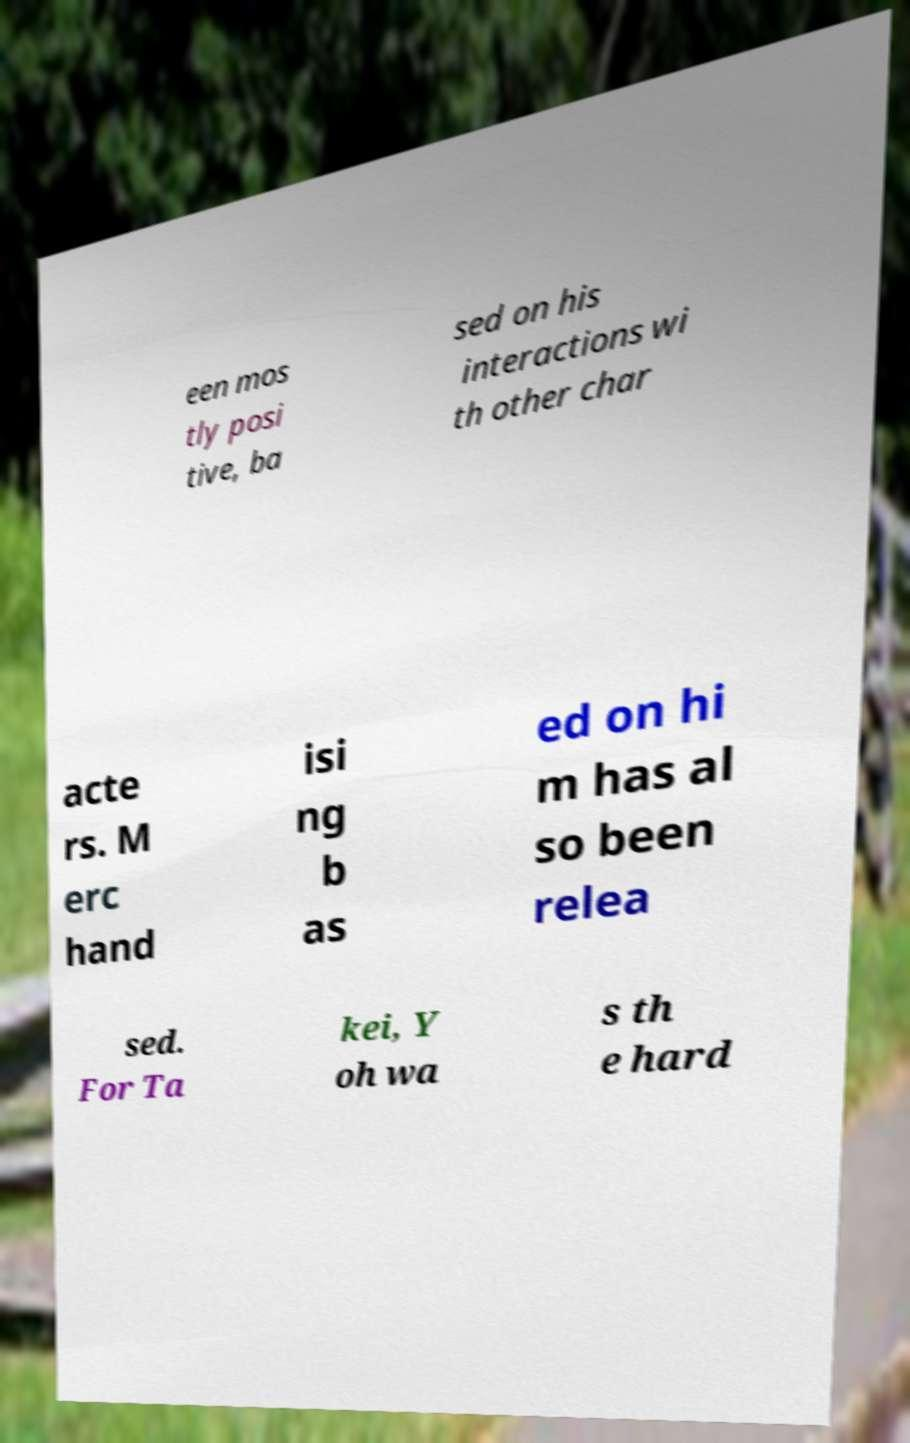Could you extract and type out the text from this image? een mos tly posi tive, ba sed on his interactions wi th other char acte rs. M erc hand isi ng b as ed on hi m has al so been relea sed. For Ta kei, Y oh wa s th e hard 